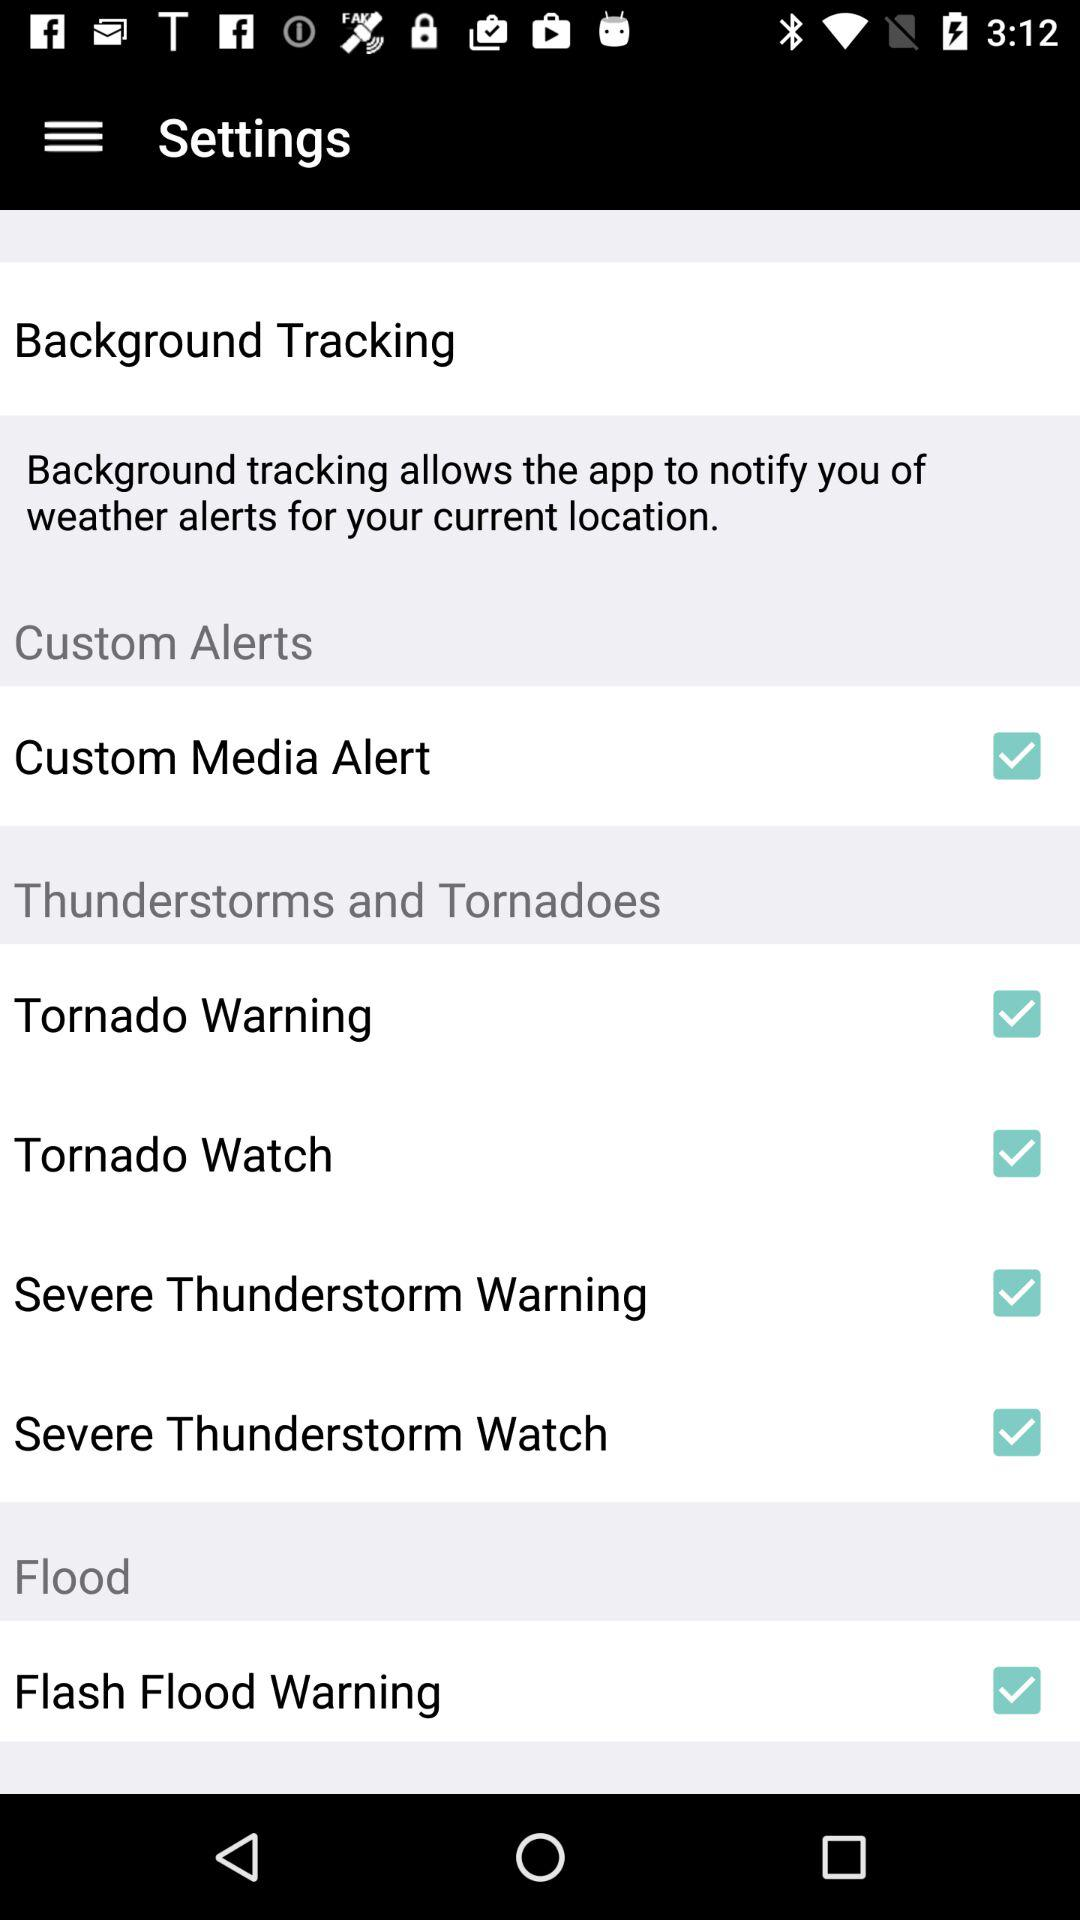What is the current status of the "Flash Flood Warning" setting? The current status of the "Flash Flood Warning" setting is "on". 